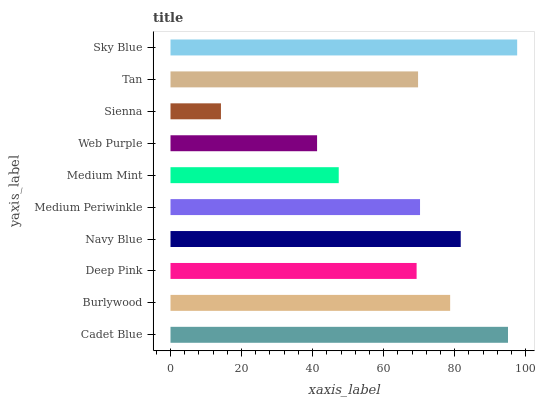Is Sienna the minimum?
Answer yes or no. Yes. Is Sky Blue the maximum?
Answer yes or no. Yes. Is Burlywood the minimum?
Answer yes or no. No. Is Burlywood the maximum?
Answer yes or no. No. Is Cadet Blue greater than Burlywood?
Answer yes or no. Yes. Is Burlywood less than Cadet Blue?
Answer yes or no. Yes. Is Burlywood greater than Cadet Blue?
Answer yes or no. No. Is Cadet Blue less than Burlywood?
Answer yes or no. No. Is Medium Periwinkle the high median?
Answer yes or no. Yes. Is Tan the low median?
Answer yes or no. Yes. Is Deep Pink the high median?
Answer yes or no. No. Is Burlywood the low median?
Answer yes or no. No. 